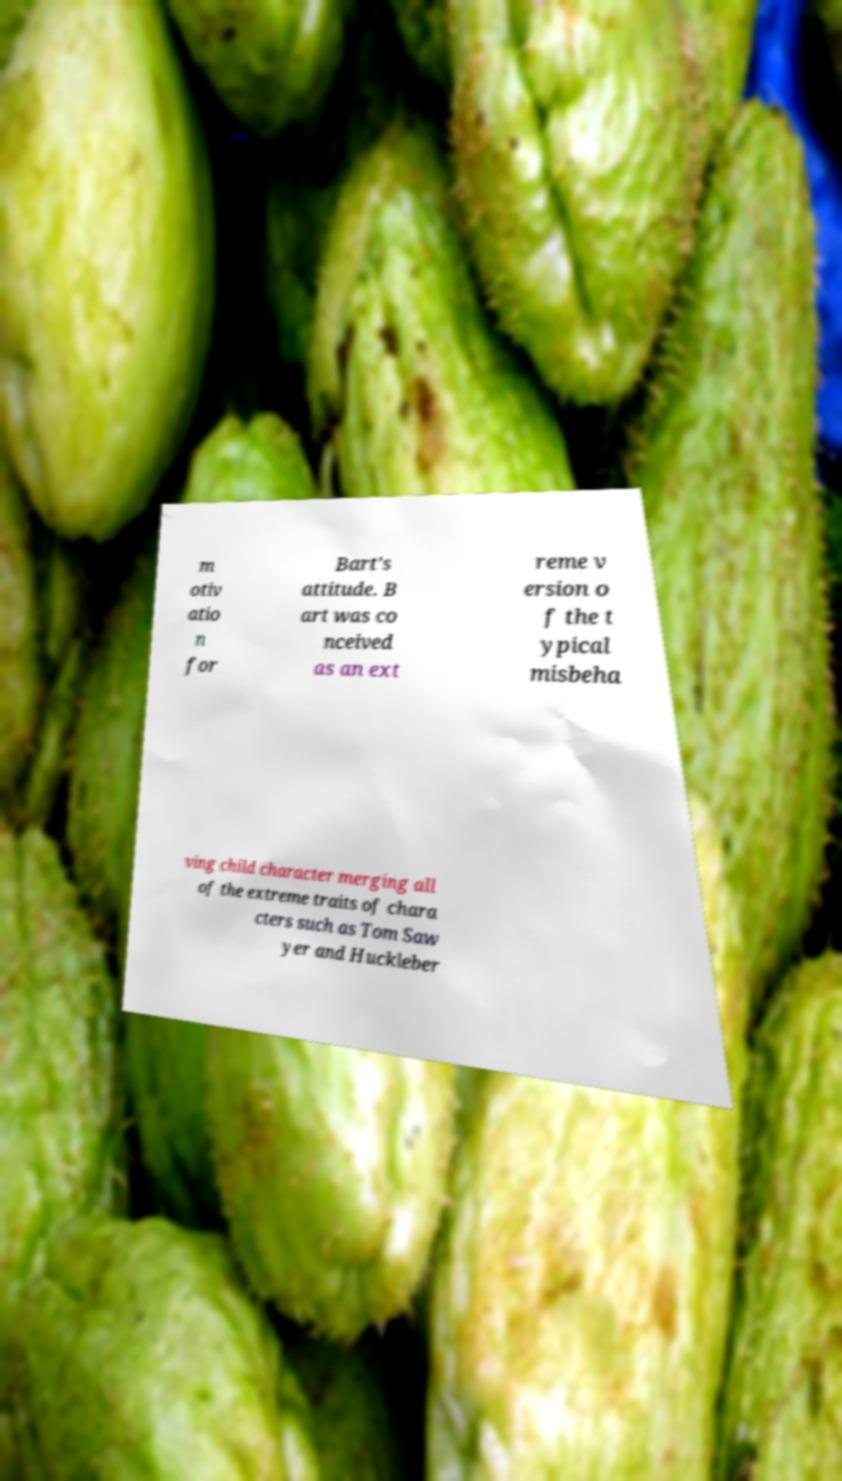What messages or text are displayed in this image? I need them in a readable, typed format. m otiv atio n for Bart's attitude. B art was co nceived as an ext reme v ersion o f the t ypical misbeha ving child character merging all of the extreme traits of chara cters such as Tom Saw yer and Huckleber 